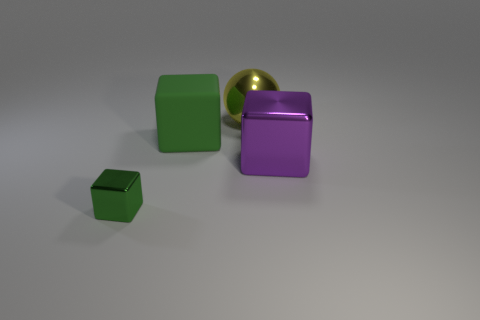There is a cube on the right side of the large yellow ball; what is its size? The cube on the right side of the large yellow ball appears to be medium-sized in relation to the other objects in the image. It is slightly larger than the small green cube but significantly smaller than the yellow ball. 